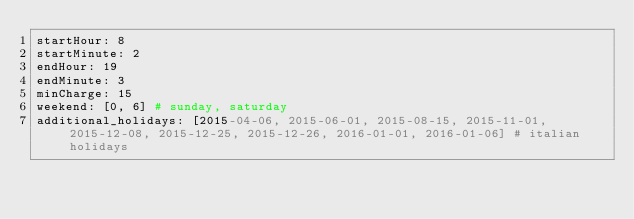Convert code to text. <code><loc_0><loc_0><loc_500><loc_500><_YAML_>startHour: 8
startMinute: 2
endHour: 19
endMinute: 3
minCharge: 15
weekend: [0, 6] # sunday, saturday
additional_holidays: [2015-04-06, 2015-06-01, 2015-08-15, 2015-11-01, 2015-12-08, 2015-12-25, 2015-12-26, 2016-01-01, 2016-01-06] # italian holidays
</code> 